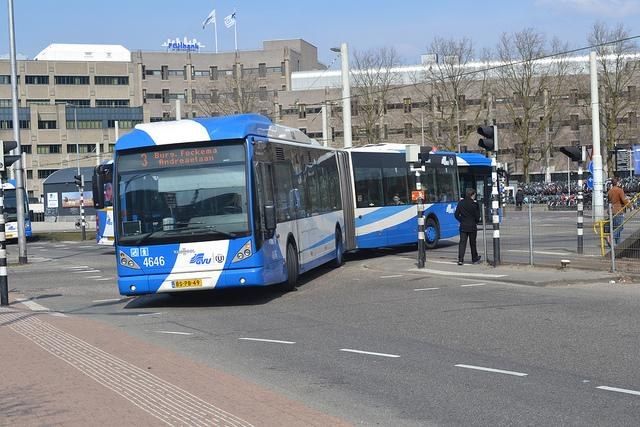What style design connects the two bus parts here?

Choices:
A) invisible
B) bolts
C) accordion
D) rope accordion 